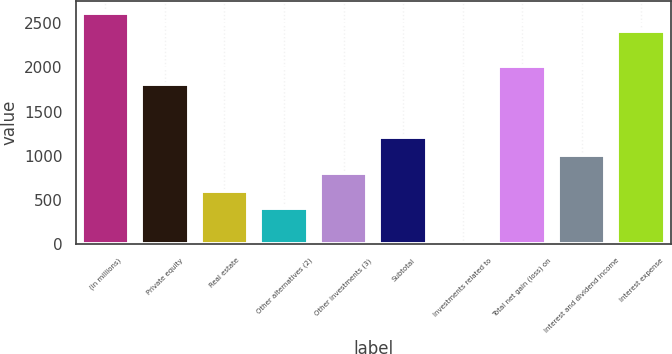Convert chart. <chart><loc_0><loc_0><loc_500><loc_500><bar_chart><fcel>(in millions)<fcel>Private equity<fcel>Real estate<fcel>Other alternatives (2)<fcel>Other investments (3)<fcel>Subtotal<fcel>Investments related to<fcel>Total net gain (loss) on<fcel>Interest and dividend income<fcel>Interest expense<nl><fcel>2619.2<fcel>1813.6<fcel>605.2<fcel>403.8<fcel>806.6<fcel>1209.4<fcel>1<fcel>2015<fcel>1008<fcel>2417.8<nl></chart> 